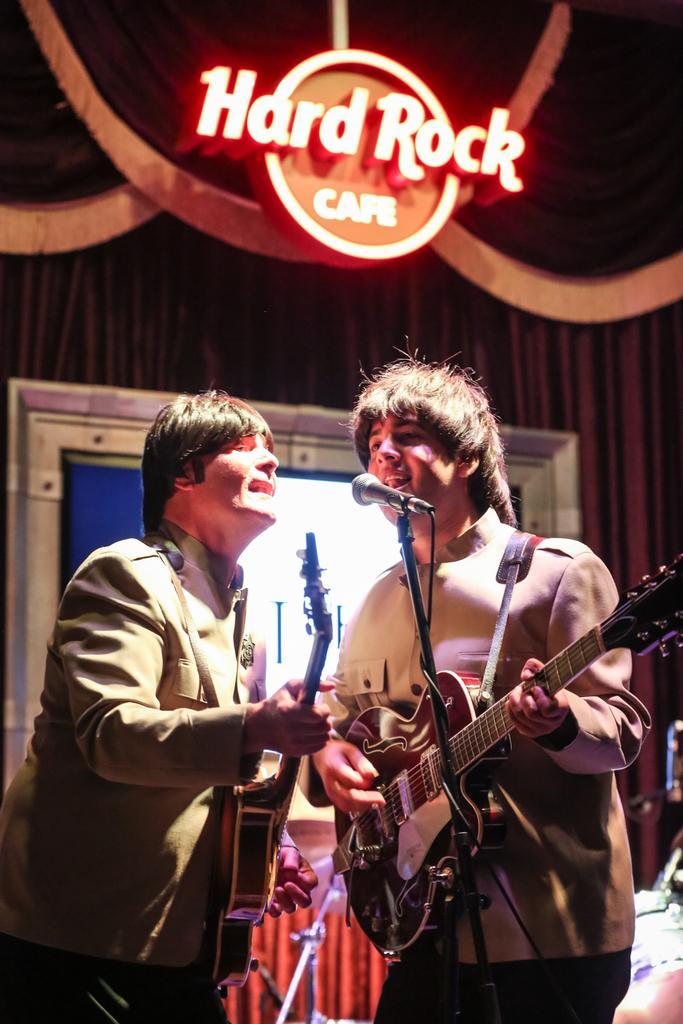In one or two sentences, can you explain what this image depicts? In this image there are two persons playing guitar and there is a mic in front of them. In the background there is a screen, curtain and at top of the image there is a logo. 